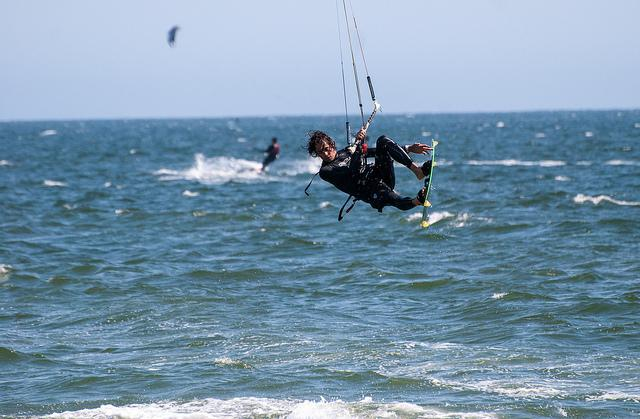What is above this person? kite 